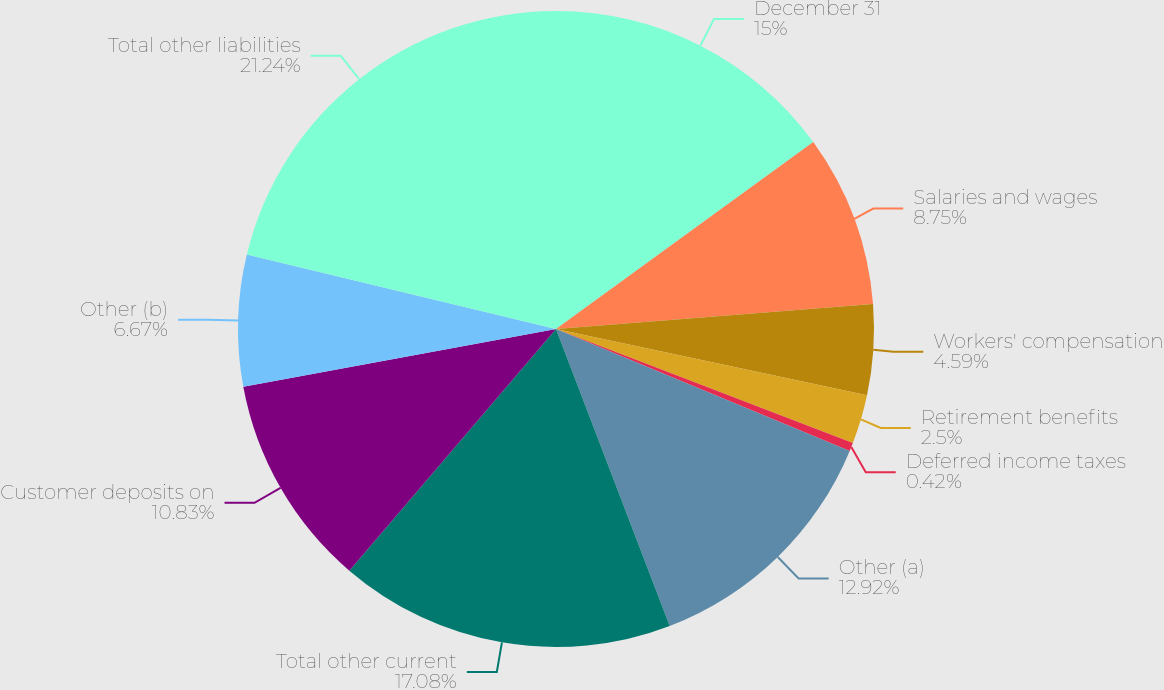Convert chart. <chart><loc_0><loc_0><loc_500><loc_500><pie_chart><fcel>December 31<fcel>Salaries and wages<fcel>Workers' compensation<fcel>Retirement benefits<fcel>Deferred income taxes<fcel>Other (a)<fcel>Total other current<fcel>Customer deposits on<fcel>Other (b)<fcel>Total other liabilities<nl><fcel>15.0%<fcel>8.75%<fcel>4.59%<fcel>2.5%<fcel>0.42%<fcel>12.92%<fcel>17.08%<fcel>10.83%<fcel>6.67%<fcel>21.24%<nl></chart> 